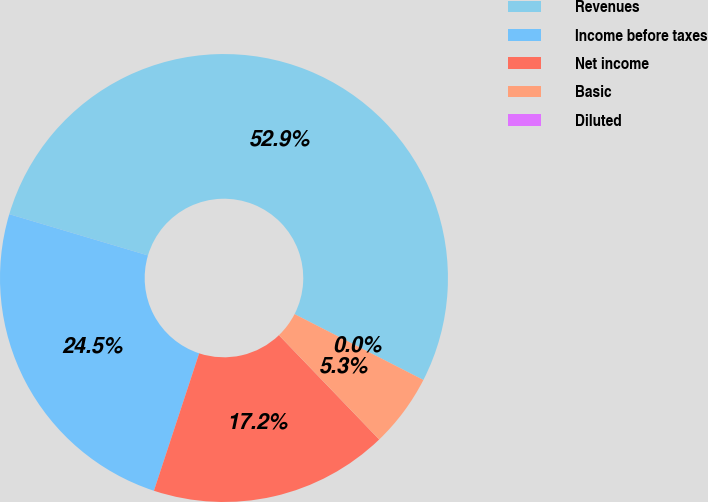<chart> <loc_0><loc_0><loc_500><loc_500><pie_chart><fcel>Revenues<fcel>Income before taxes<fcel>Net income<fcel>Basic<fcel>Diluted<nl><fcel>52.92%<fcel>24.54%<fcel>17.25%<fcel>5.29%<fcel>0.0%<nl></chart> 